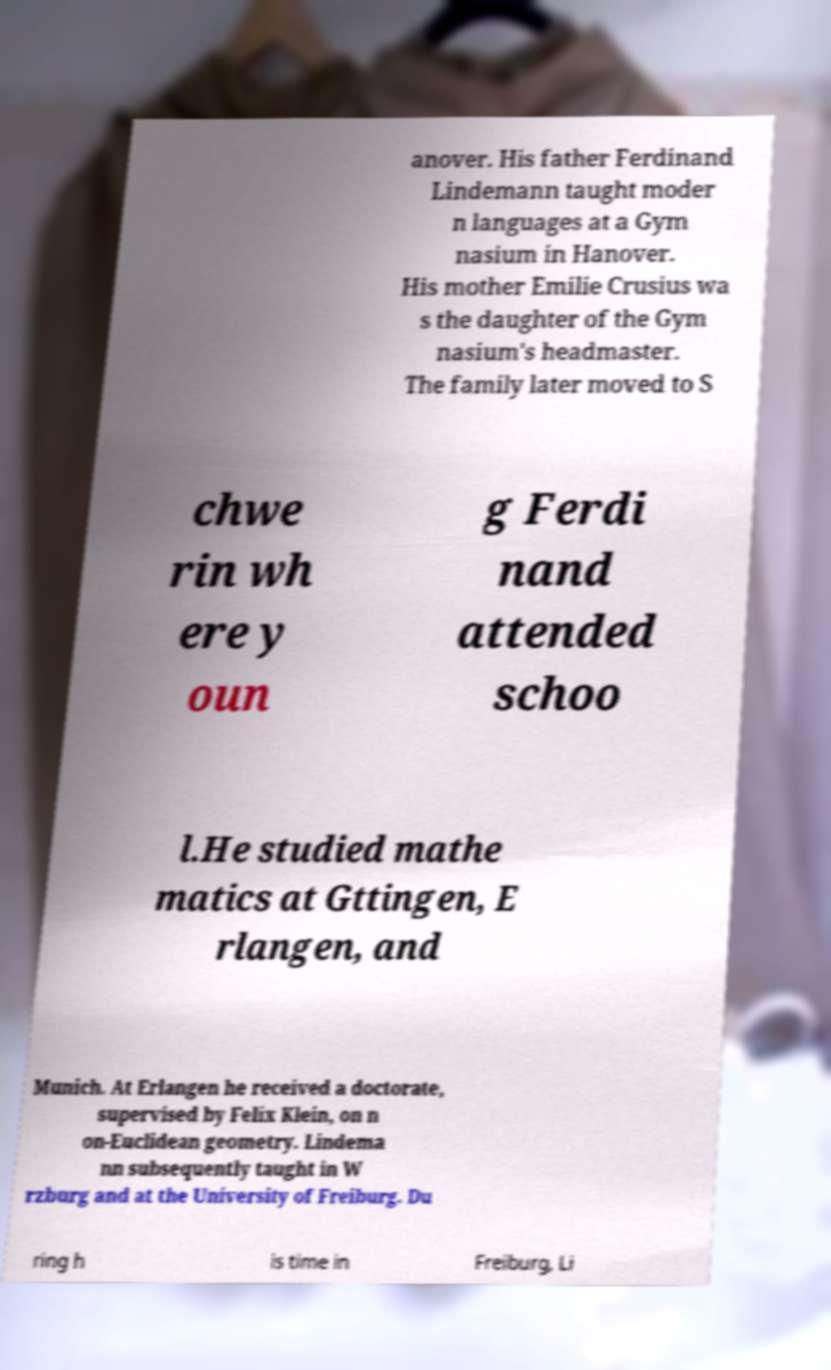Please identify and transcribe the text found in this image. anover. His father Ferdinand Lindemann taught moder n languages at a Gym nasium in Hanover. His mother Emilie Crusius wa s the daughter of the Gym nasium's headmaster. The family later moved to S chwe rin wh ere y oun g Ferdi nand attended schoo l.He studied mathe matics at Gttingen, E rlangen, and Munich. At Erlangen he received a doctorate, supervised by Felix Klein, on n on-Euclidean geometry. Lindema nn subsequently taught in W rzburg and at the University of Freiburg. Du ring h is time in Freiburg, Li 